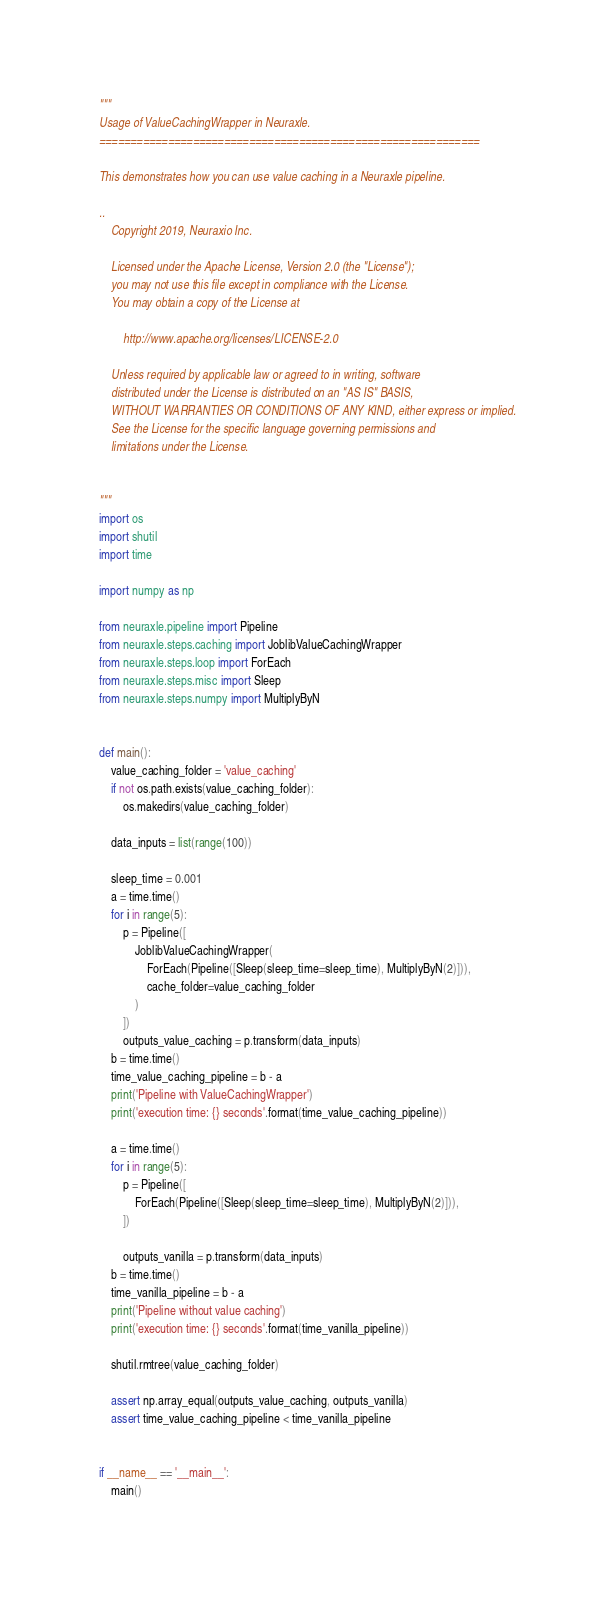Convert code to text. <code><loc_0><loc_0><loc_500><loc_500><_Python_>"""
Usage of ValueCachingWrapper in Neuraxle.
=============================================================

This demonstrates how you can use value caching in a Neuraxle pipeline.

..
    Copyright 2019, Neuraxio Inc.

    Licensed under the Apache License, Version 2.0 (the "License");
    you may not use this file except in compliance with the License.
    You may obtain a copy of the License at

        http://www.apache.org/licenses/LICENSE-2.0

    Unless required by applicable law or agreed to in writing, software
    distributed under the License is distributed on an "AS IS" BASIS,
    WITHOUT WARRANTIES OR CONDITIONS OF ANY KIND, either express or implied.
    See the License for the specific language governing permissions and
    limitations under the License.


"""
import os
import shutil
import time

import numpy as np

from neuraxle.pipeline import Pipeline
from neuraxle.steps.caching import JoblibValueCachingWrapper
from neuraxle.steps.loop import ForEach
from neuraxle.steps.misc import Sleep
from neuraxle.steps.numpy import MultiplyByN


def main():
    value_caching_folder = 'value_caching'
    if not os.path.exists(value_caching_folder):
        os.makedirs(value_caching_folder)

    data_inputs = list(range(100))

    sleep_time = 0.001
    a = time.time()
    for i in range(5):
        p = Pipeline([
            JoblibValueCachingWrapper(
                ForEach(Pipeline([Sleep(sleep_time=sleep_time), MultiplyByN(2)])),
                cache_folder=value_caching_folder
            )
        ])
        outputs_value_caching = p.transform(data_inputs)
    b = time.time()
    time_value_caching_pipeline = b - a
    print('Pipeline with ValueCachingWrapper')
    print('execution time: {} seconds'.format(time_value_caching_pipeline))

    a = time.time()
    for i in range(5):
        p = Pipeline([
            ForEach(Pipeline([Sleep(sleep_time=sleep_time), MultiplyByN(2)])),
        ])

        outputs_vanilla = p.transform(data_inputs)
    b = time.time()
    time_vanilla_pipeline = b - a
    print('Pipeline without value caching')
    print('execution time: {} seconds'.format(time_vanilla_pipeline))

    shutil.rmtree(value_caching_folder)

    assert np.array_equal(outputs_value_caching, outputs_vanilla)
    assert time_value_caching_pipeline < time_vanilla_pipeline


if __name__ == '__main__':
    main()
</code> 